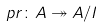Convert formula to latex. <formula><loc_0><loc_0><loc_500><loc_500>p r \colon A \twoheadrightarrow A / I</formula> 